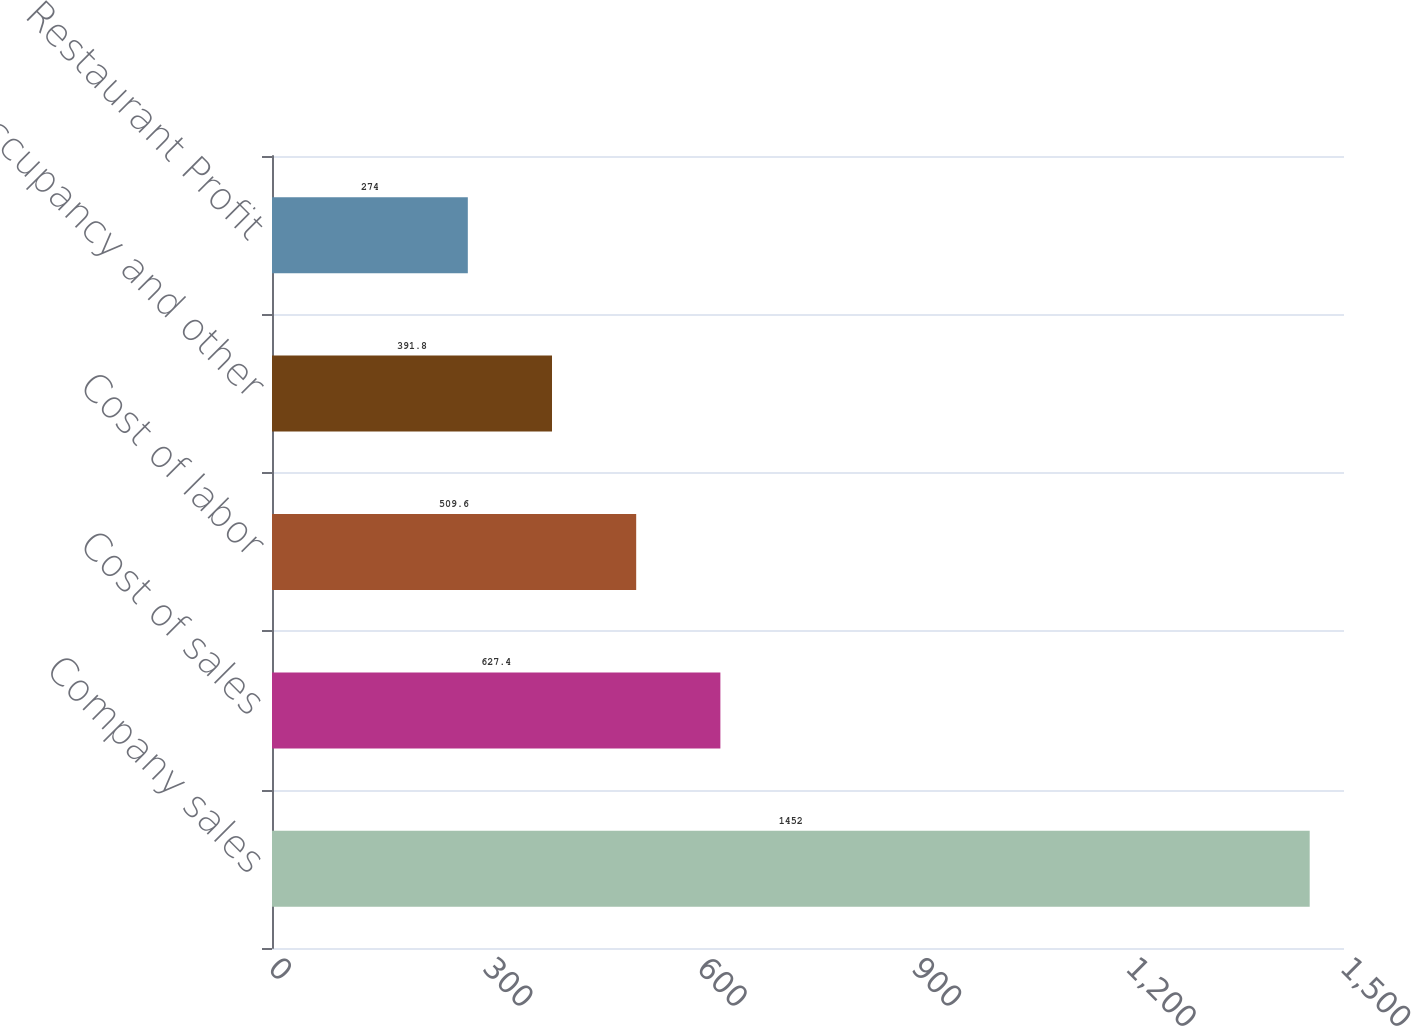Convert chart to OTSL. <chart><loc_0><loc_0><loc_500><loc_500><bar_chart><fcel>Company sales<fcel>Cost of sales<fcel>Cost of labor<fcel>Occupancy and other<fcel>Restaurant Profit<nl><fcel>1452<fcel>627.4<fcel>509.6<fcel>391.8<fcel>274<nl></chart> 